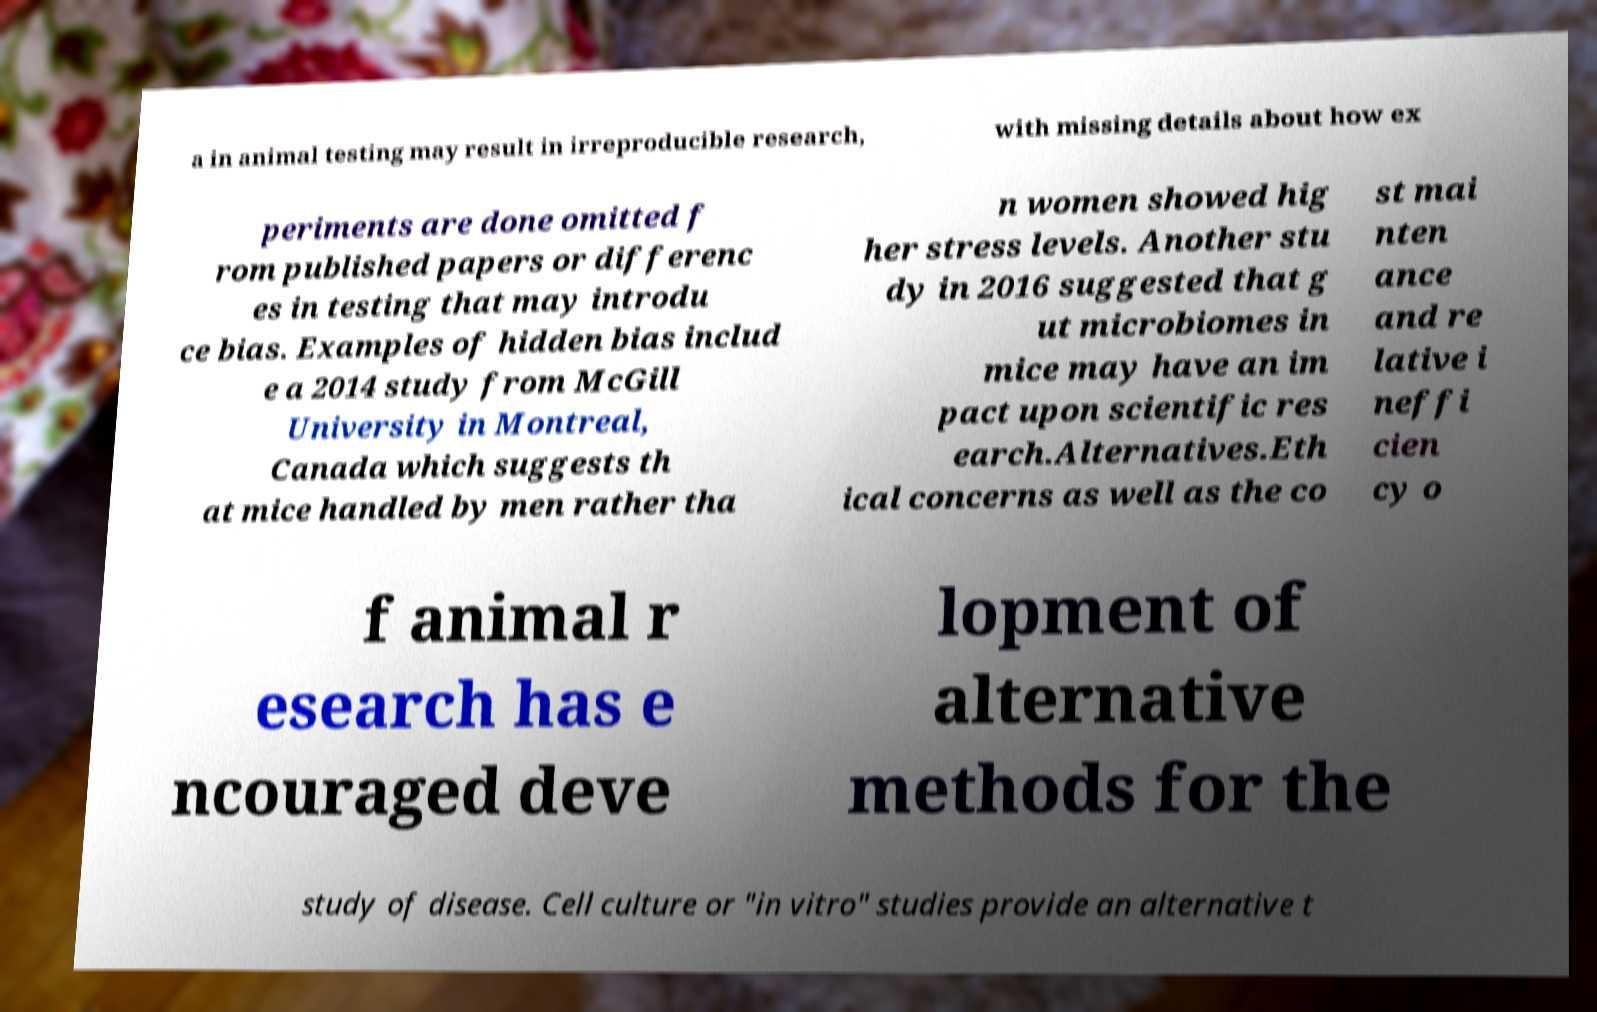Can you read and provide the text displayed in the image?This photo seems to have some interesting text. Can you extract and type it out for me? a in animal testing may result in irreproducible research, with missing details about how ex periments are done omitted f rom published papers or differenc es in testing that may introdu ce bias. Examples of hidden bias includ e a 2014 study from McGill University in Montreal, Canada which suggests th at mice handled by men rather tha n women showed hig her stress levels. Another stu dy in 2016 suggested that g ut microbiomes in mice may have an im pact upon scientific res earch.Alternatives.Eth ical concerns as well as the co st mai nten ance and re lative i neffi cien cy o f animal r esearch has e ncouraged deve lopment of alternative methods for the study of disease. Cell culture or "in vitro" studies provide an alternative t 